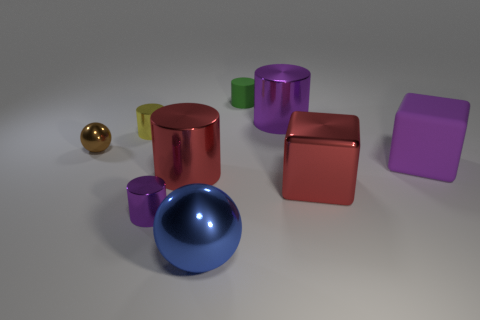Subtract all purple cylinders. How many were subtracted if there are1purple cylinders left? 1 Subtract all small green cylinders. How many cylinders are left? 4 Subtract all green cylinders. How many cylinders are left? 4 Subtract all gray cylinders. Subtract all yellow spheres. How many cylinders are left? 5 Subtract all balls. How many objects are left? 7 Subtract 0 yellow blocks. How many objects are left? 9 Subtract all brown objects. Subtract all rubber things. How many objects are left? 6 Add 1 matte things. How many matte things are left? 3 Add 4 large blue balls. How many large blue balls exist? 5 